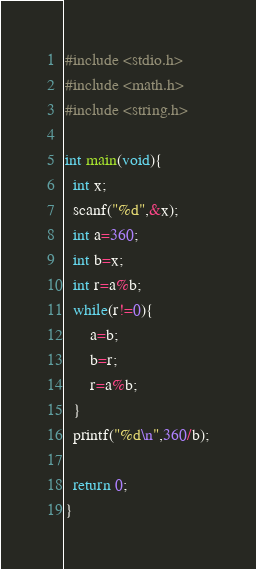<code> <loc_0><loc_0><loc_500><loc_500><_C_>#include <stdio.h>
#include <math.h>
#include <string.h>

int main(void){
  int x;
  scanf("%d",&x);
  int a=360;
  int b=x;
  int r=a%b;
  while(r!=0){
      a=b;
      b=r;
      r=a%b;
  }
  printf("%d\n",360/b);

  return 0;
}</code> 